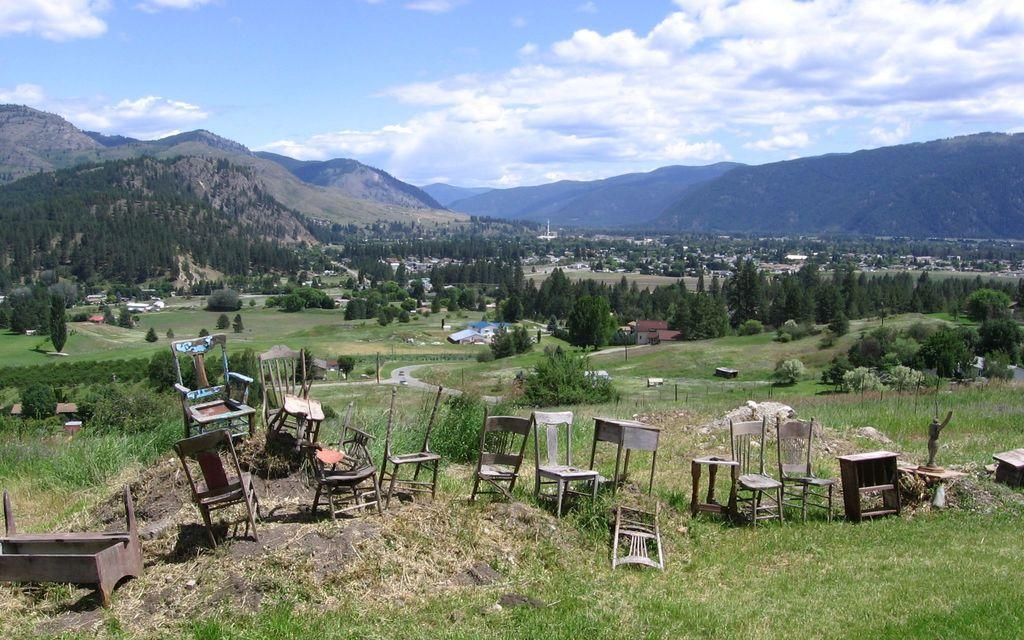What type of natural vegetation can be seen in the image? There are trees in the image. What type of geographical feature is present in the image? There are mountains in the image. What type of man-made structures can be seen in the image? There are houses in the image. What type of utility objects can be seen in the image? There are poles in the image. What type of furniture can be seen in the image? There are chairs in the image. What type of ground cover can be seen in the image? There is grass in the image. What type of artistic object can be seen in the image? There is a statue in the image. What type of flat surfaces can be seen in the image? There are tables in the image. What type of material is used for some objects in the image? There are wooden objects in the image. What is the color of the sky in the image? The sky is blue and white in color. How many pigs are sitting on the tub in the image? There are no pigs or tubs present in the image. What type of finger can be seen interacting with the statue in the image? There are no fingers interacting with the statue in the image. 